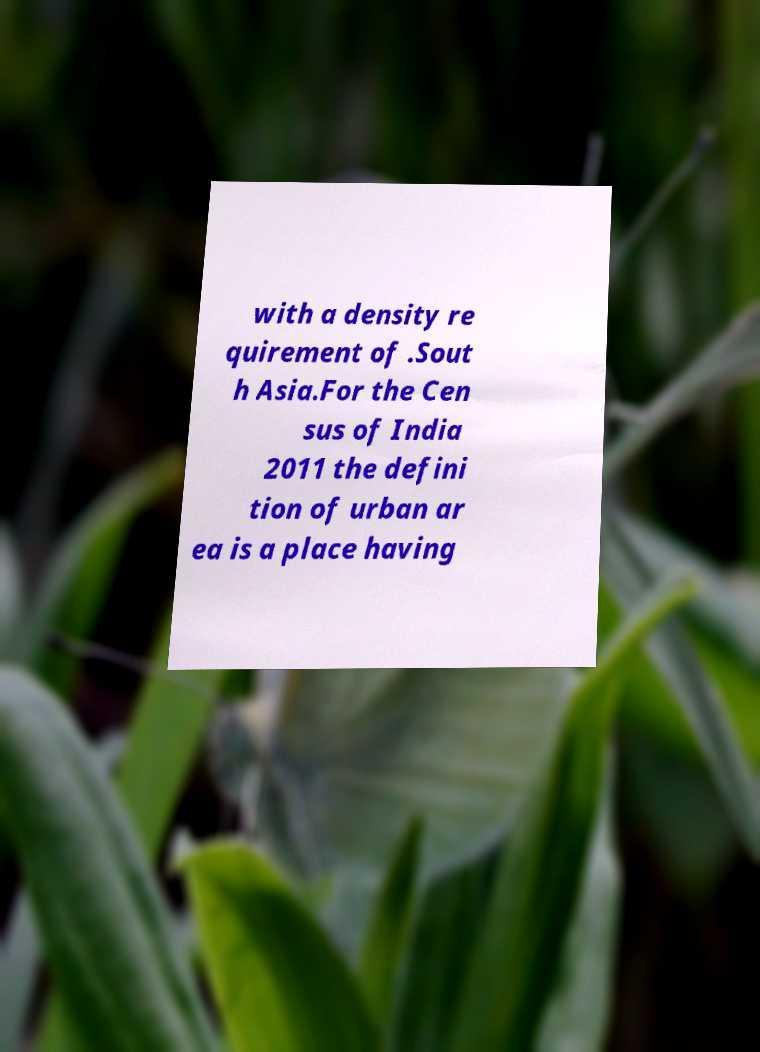There's text embedded in this image that I need extracted. Can you transcribe it verbatim? with a density re quirement of .Sout h Asia.For the Cen sus of India 2011 the defini tion of urban ar ea is a place having 